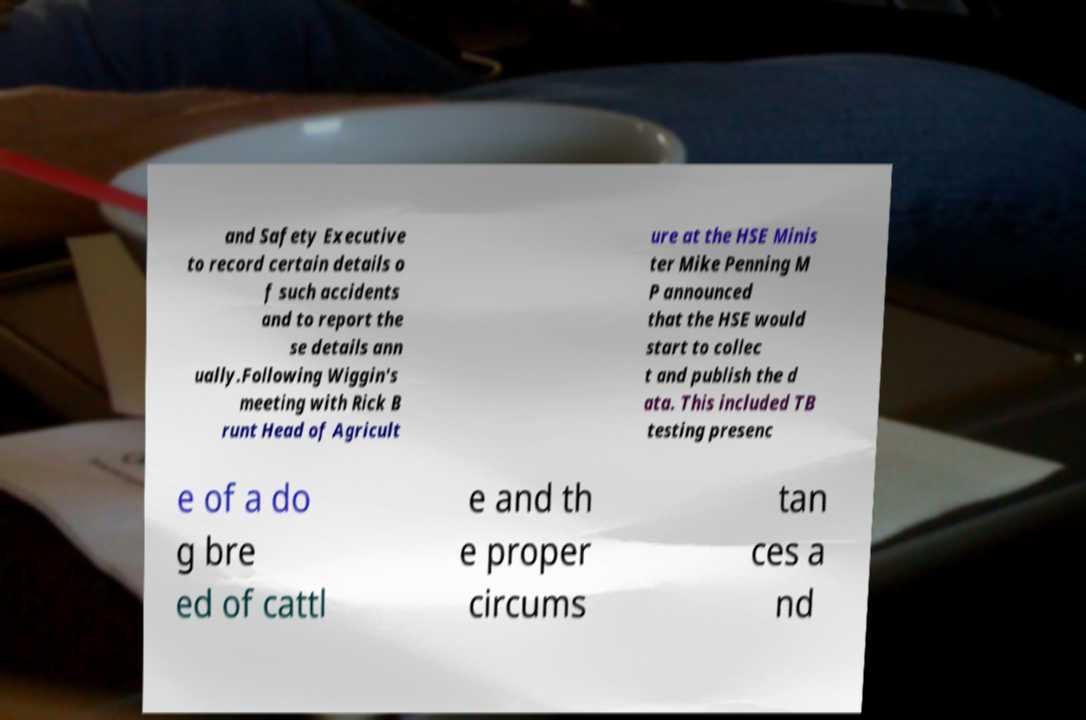Please identify and transcribe the text found in this image. and Safety Executive to record certain details o f such accidents and to report the se details ann ually.Following Wiggin's meeting with Rick B runt Head of Agricult ure at the HSE Minis ter Mike Penning M P announced that the HSE would start to collec t and publish the d ata. This included TB testing presenc e of a do g bre ed of cattl e and th e proper circums tan ces a nd 